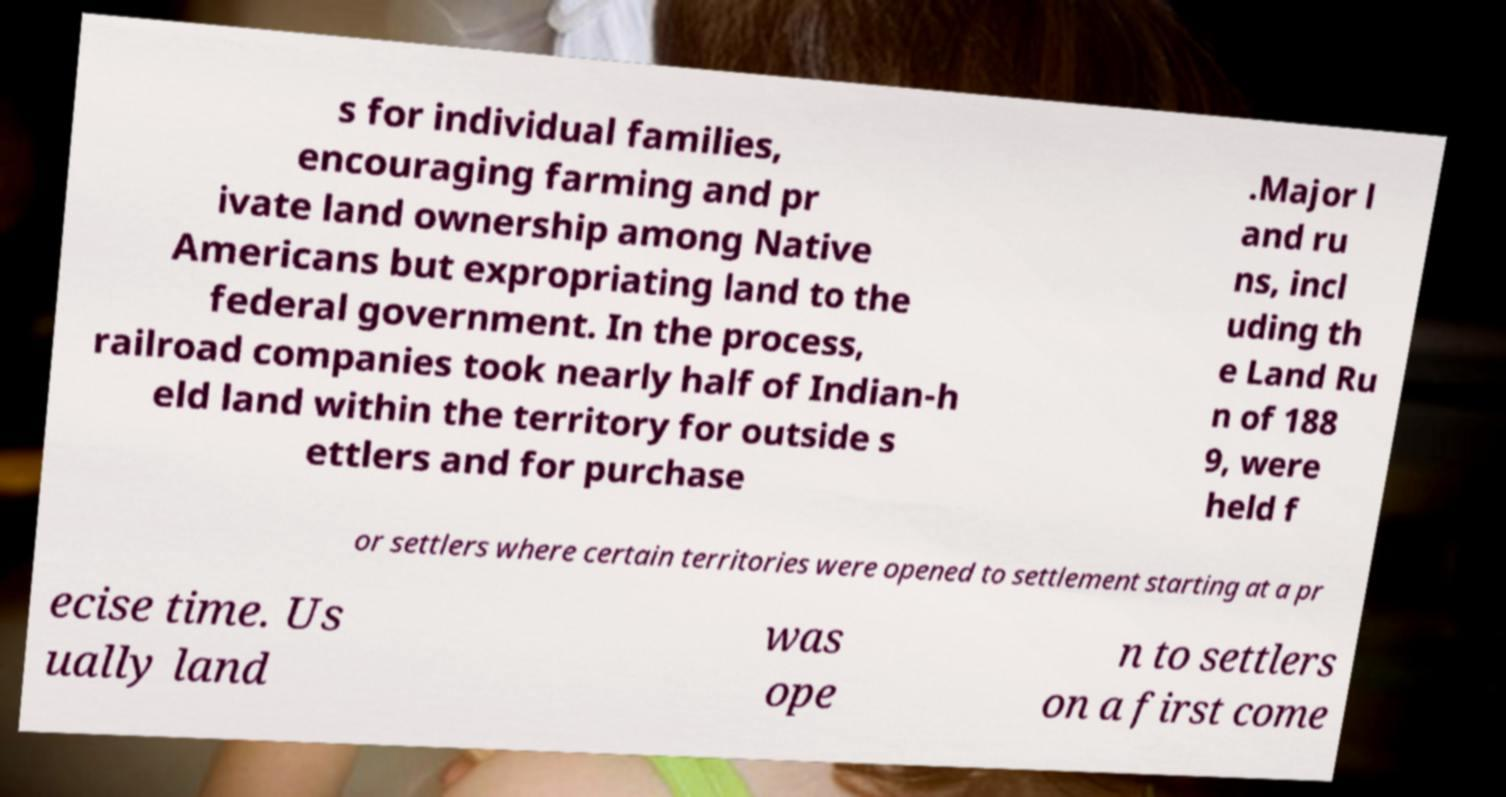Please read and relay the text visible in this image. What does it say? s for individual families, encouraging farming and pr ivate land ownership among Native Americans but expropriating land to the federal government. In the process, railroad companies took nearly half of Indian-h eld land within the territory for outside s ettlers and for purchase .Major l and ru ns, incl uding th e Land Ru n of 188 9, were held f or settlers where certain territories were opened to settlement starting at a pr ecise time. Us ually land was ope n to settlers on a first come 